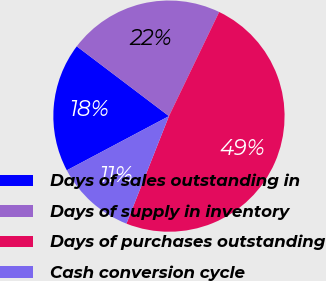Convert chart to OTSL. <chart><loc_0><loc_0><loc_500><loc_500><pie_chart><fcel>Days of sales outstanding in<fcel>Days of supply in inventory<fcel>Days of purchases outstanding<fcel>Cash conversion cycle<nl><fcel>18.08%<fcel>21.84%<fcel>48.85%<fcel>11.24%<nl></chart> 